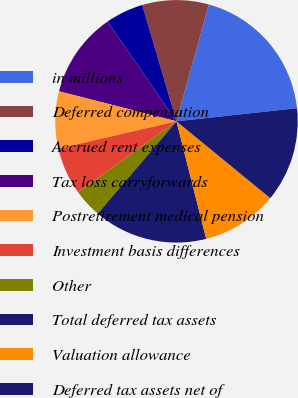<chart> <loc_0><loc_0><loc_500><loc_500><pie_chart><fcel>in millions<fcel>Deferred compensation<fcel>Accrued rent expenses<fcel>Tax loss carryforwards<fcel>Postretirement medical pension<fcel>Investment basis differences<fcel>Other<fcel>Total deferred tax assets<fcel>Valuation allowance<fcel>Deferred tax assets net of<nl><fcel>18.97%<fcel>8.86%<fcel>5.07%<fcel>11.39%<fcel>7.6%<fcel>6.34%<fcel>3.81%<fcel>15.18%<fcel>10.13%<fcel>12.65%<nl></chart> 